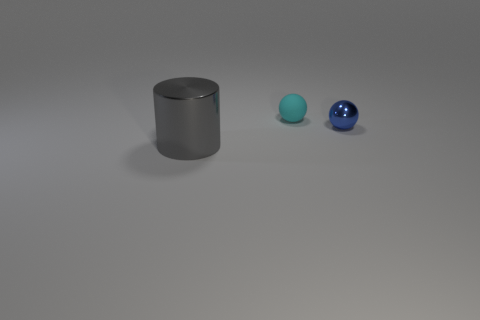Add 2 tiny blue balls. How many objects exist? 5 Subtract 1 cylinders. How many cylinders are left? 0 Add 3 large yellow rubber things. How many large yellow rubber things exist? 3 Subtract all blue balls. How many balls are left? 1 Subtract 1 cyan balls. How many objects are left? 2 Subtract all spheres. How many objects are left? 1 Subtract all blue spheres. Subtract all yellow cubes. How many spheres are left? 1 Subtract all purple spheres. How many brown cylinders are left? 0 Subtract all cyan objects. Subtract all big shiny cylinders. How many objects are left? 1 Add 3 blue things. How many blue things are left? 4 